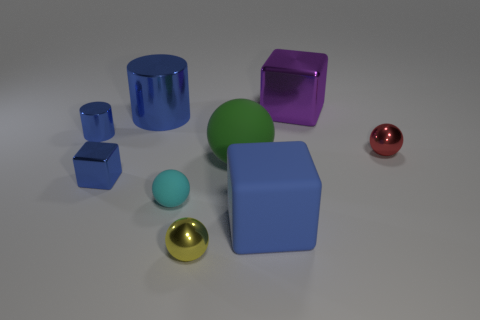Which objects in this image could be used to store a small amount of liquid? The cylindrical blue cup and the spherical golden bowl appear suitable for holding a small amount of liquid. 